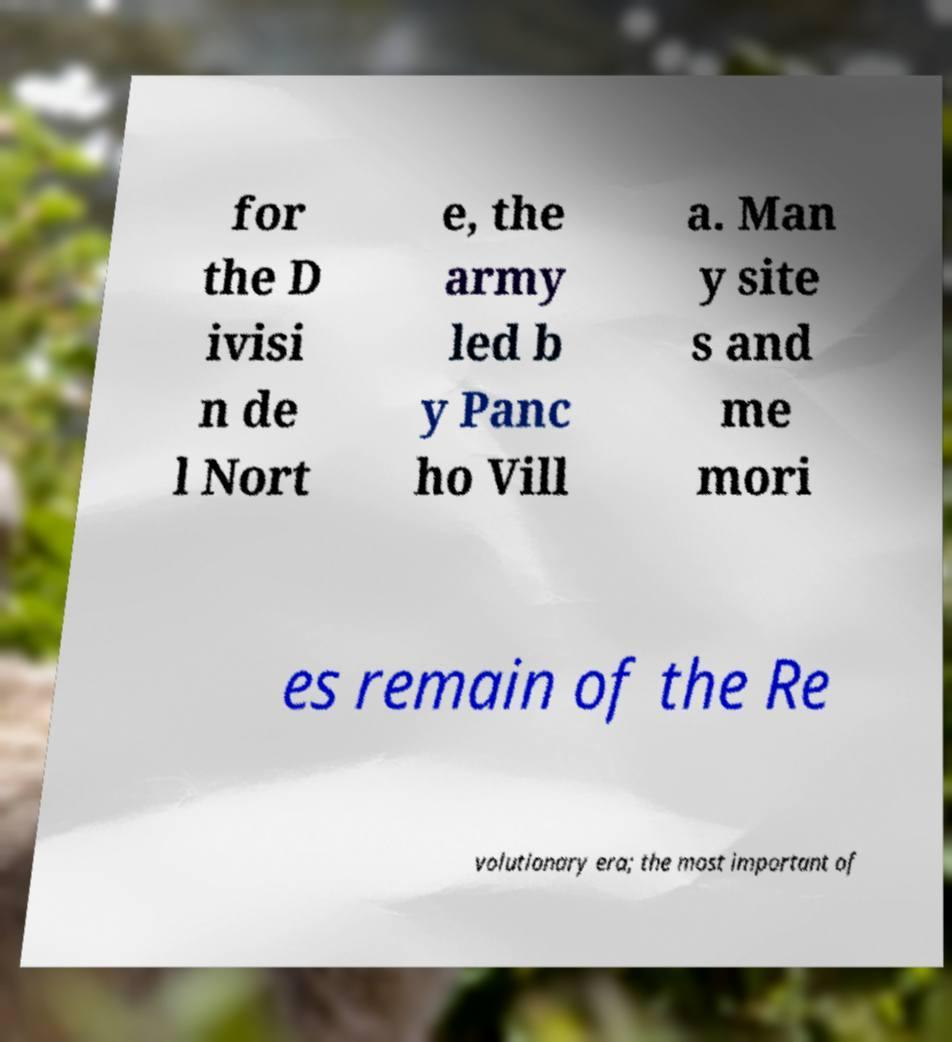Could you assist in decoding the text presented in this image and type it out clearly? for the D ivisi n de l Nort e, the army led b y Panc ho Vill a. Man y site s and me mori es remain of the Re volutionary era; the most important of 